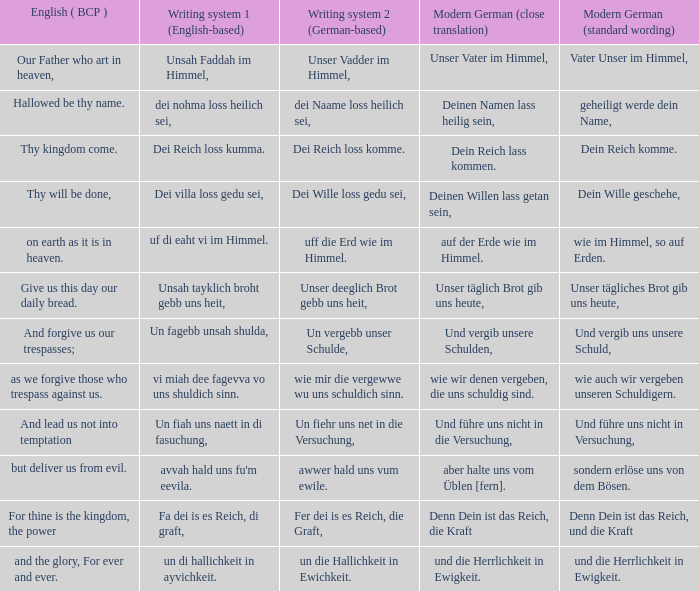What is the english (bcp) phrase "for thine is the kingdom, the power" in modern german with standard wording? Denn Dein ist das Reich, und die Kraft. 